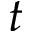Convert formula to latex. <formula><loc_0><loc_0><loc_500><loc_500>t</formula> 